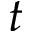Convert formula to latex. <formula><loc_0><loc_0><loc_500><loc_500>t</formula> 